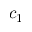Convert formula to latex. <formula><loc_0><loc_0><loc_500><loc_500>c _ { 1 }</formula> 